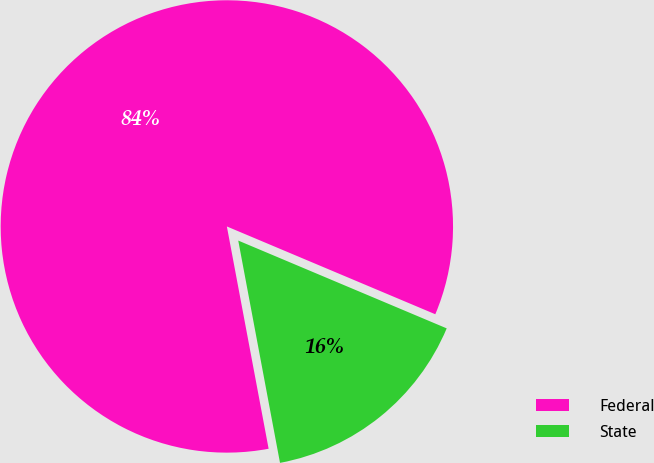<chart> <loc_0><loc_0><loc_500><loc_500><pie_chart><fcel>Federal<fcel>State<nl><fcel>84.3%<fcel>15.7%<nl></chart> 